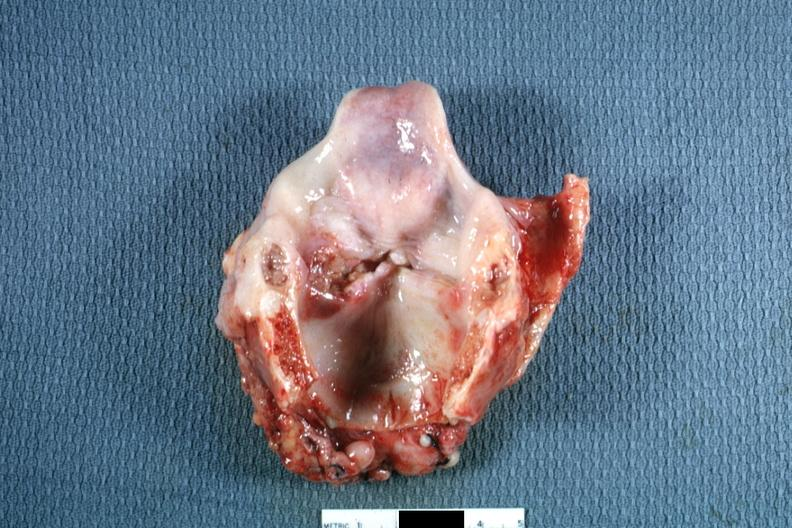what is present?
Answer the question using a single word or phrase. Larynx 